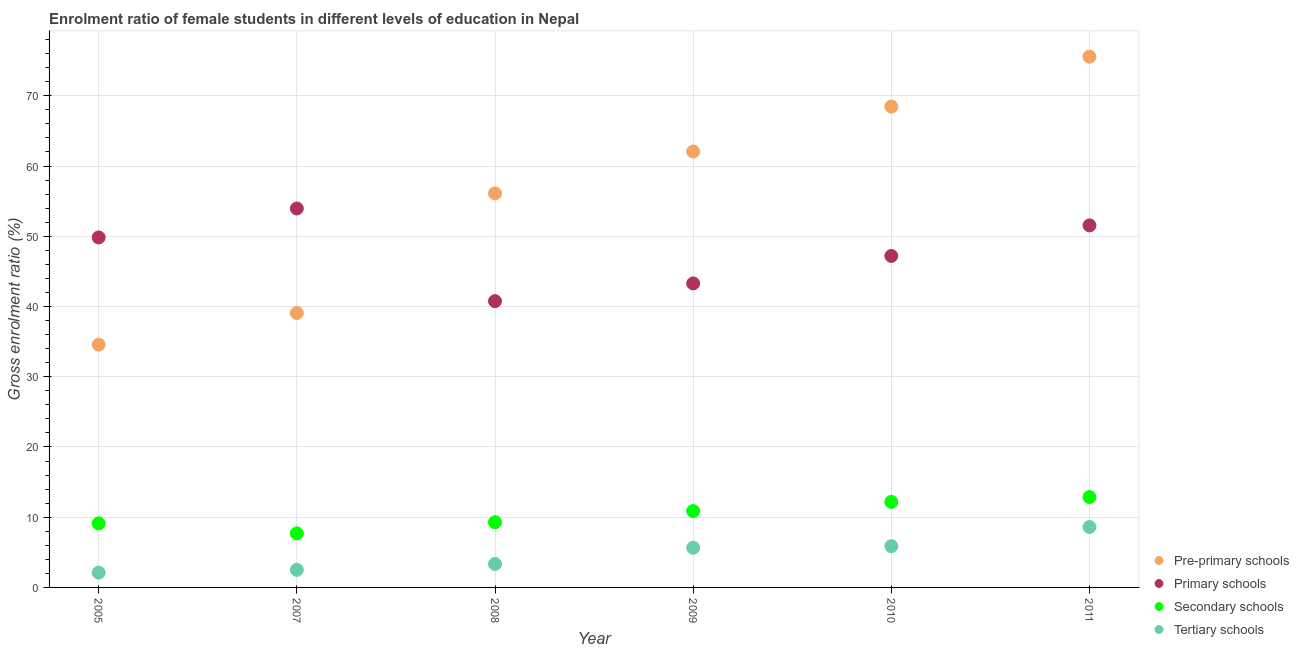How many different coloured dotlines are there?
Provide a short and direct response. 4. Is the number of dotlines equal to the number of legend labels?
Your answer should be compact. Yes. What is the gross enrolment ratio(male) in pre-primary schools in 2009?
Give a very brief answer. 62.07. Across all years, what is the maximum gross enrolment ratio(male) in secondary schools?
Ensure brevity in your answer.  12.86. Across all years, what is the minimum gross enrolment ratio(male) in pre-primary schools?
Offer a very short reply. 34.57. In which year was the gross enrolment ratio(male) in tertiary schools maximum?
Your response must be concise. 2011. What is the total gross enrolment ratio(male) in secondary schools in the graph?
Offer a very short reply. 62. What is the difference between the gross enrolment ratio(male) in pre-primary schools in 2007 and that in 2008?
Ensure brevity in your answer.  -17.03. What is the difference between the gross enrolment ratio(male) in secondary schools in 2010 and the gross enrolment ratio(male) in tertiary schools in 2009?
Provide a succinct answer. 6.53. What is the average gross enrolment ratio(male) in secondary schools per year?
Provide a succinct answer. 10.33. In the year 2011, what is the difference between the gross enrolment ratio(male) in secondary schools and gross enrolment ratio(male) in pre-primary schools?
Offer a very short reply. -62.71. In how many years, is the gross enrolment ratio(male) in tertiary schools greater than 16 %?
Your response must be concise. 0. What is the ratio of the gross enrolment ratio(male) in primary schools in 2007 to that in 2009?
Provide a succinct answer. 1.25. Is the difference between the gross enrolment ratio(male) in tertiary schools in 2005 and 2011 greater than the difference between the gross enrolment ratio(male) in secondary schools in 2005 and 2011?
Offer a very short reply. No. What is the difference between the highest and the second highest gross enrolment ratio(male) in tertiary schools?
Ensure brevity in your answer.  2.73. What is the difference between the highest and the lowest gross enrolment ratio(male) in secondary schools?
Provide a short and direct response. 5.17. In how many years, is the gross enrolment ratio(male) in secondary schools greater than the average gross enrolment ratio(male) in secondary schools taken over all years?
Make the answer very short. 3. Is the sum of the gross enrolment ratio(male) in primary schools in 2010 and 2011 greater than the maximum gross enrolment ratio(male) in pre-primary schools across all years?
Offer a very short reply. Yes. Is the gross enrolment ratio(male) in tertiary schools strictly less than the gross enrolment ratio(male) in secondary schools over the years?
Your response must be concise. Yes. How many dotlines are there?
Offer a terse response. 4. How many years are there in the graph?
Offer a terse response. 6. What is the difference between two consecutive major ticks on the Y-axis?
Provide a succinct answer. 10. Are the values on the major ticks of Y-axis written in scientific E-notation?
Make the answer very short. No. Does the graph contain any zero values?
Make the answer very short. No. Where does the legend appear in the graph?
Provide a short and direct response. Bottom right. How are the legend labels stacked?
Offer a very short reply. Vertical. What is the title of the graph?
Ensure brevity in your answer.  Enrolment ratio of female students in different levels of education in Nepal. Does "Energy" appear as one of the legend labels in the graph?
Your answer should be very brief. No. What is the label or title of the X-axis?
Offer a terse response. Year. What is the label or title of the Y-axis?
Offer a very short reply. Gross enrolment ratio (%). What is the Gross enrolment ratio (%) in Pre-primary schools in 2005?
Make the answer very short. 34.57. What is the Gross enrolment ratio (%) of Primary schools in 2005?
Provide a succinct answer. 49.83. What is the Gross enrolment ratio (%) in Secondary schools in 2005?
Offer a terse response. 9.12. What is the Gross enrolment ratio (%) in Tertiary schools in 2005?
Your answer should be very brief. 2.1. What is the Gross enrolment ratio (%) in Pre-primary schools in 2007?
Make the answer very short. 39.07. What is the Gross enrolment ratio (%) of Primary schools in 2007?
Provide a succinct answer. 53.95. What is the Gross enrolment ratio (%) in Secondary schools in 2007?
Offer a very short reply. 7.69. What is the Gross enrolment ratio (%) in Tertiary schools in 2007?
Your answer should be compact. 2.5. What is the Gross enrolment ratio (%) in Pre-primary schools in 2008?
Your response must be concise. 56.1. What is the Gross enrolment ratio (%) of Primary schools in 2008?
Provide a short and direct response. 40.76. What is the Gross enrolment ratio (%) in Secondary schools in 2008?
Offer a terse response. 9.28. What is the Gross enrolment ratio (%) of Tertiary schools in 2008?
Provide a short and direct response. 3.34. What is the Gross enrolment ratio (%) of Pre-primary schools in 2009?
Your response must be concise. 62.07. What is the Gross enrolment ratio (%) of Primary schools in 2009?
Make the answer very short. 43.28. What is the Gross enrolment ratio (%) of Secondary schools in 2009?
Provide a succinct answer. 10.87. What is the Gross enrolment ratio (%) of Tertiary schools in 2009?
Provide a short and direct response. 5.65. What is the Gross enrolment ratio (%) of Pre-primary schools in 2010?
Provide a short and direct response. 68.46. What is the Gross enrolment ratio (%) of Primary schools in 2010?
Provide a short and direct response. 47.2. What is the Gross enrolment ratio (%) in Secondary schools in 2010?
Your response must be concise. 12.18. What is the Gross enrolment ratio (%) of Tertiary schools in 2010?
Provide a short and direct response. 5.88. What is the Gross enrolment ratio (%) of Pre-primary schools in 2011?
Keep it short and to the point. 75.58. What is the Gross enrolment ratio (%) of Primary schools in 2011?
Make the answer very short. 51.54. What is the Gross enrolment ratio (%) in Secondary schools in 2011?
Ensure brevity in your answer.  12.86. What is the Gross enrolment ratio (%) in Tertiary schools in 2011?
Give a very brief answer. 8.6. Across all years, what is the maximum Gross enrolment ratio (%) in Pre-primary schools?
Offer a terse response. 75.58. Across all years, what is the maximum Gross enrolment ratio (%) in Primary schools?
Provide a short and direct response. 53.95. Across all years, what is the maximum Gross enrolment ratio (%) in Secondary schools?
Your answer should be very brief. 12.86. Across all years, what is the maximum Gross enrolment ratio (%) in Tertiary schools?
Keep it short and to the point. 8.6. Across all years, what is the minimum Gross enrolment ratio (%) in Pre-primary schools?
Make the answer very short. 34.57. Across all years, what is the minimum Gross enrolment ratio (%) of Primary schools?
Provide a succinct answer. 40.76. Across all years, what is the minimum Gross enrolment ratio (%) of Secondary schools?
Ensure brevity in your answer.  7.69. Across all years, what is the minimum Gross enrolment ratio (%) of Tertiary schools?
Your answer should be very brief. 2.1. What is the total Gross enrolment ratio (%) of Pre-primary schools in the graph?
Keep it short and to the point. 335.84. What is the total Gross enrolment ratio (%) in Primary schools in the graph?
Offer a very short reply. 286.57. What is the total Gross enrolment ratio (%) in Secondary schools in the graph?
Offer a very short reply. 62. What is the total Gross enrolment ratio (%) in Tertiary schools in the graph?
Make the answer very short. 28.08. What is the difference between the Gross enrolment ratio (%) of Pre-primary schools in 2005 and that in 2007?
Provide a succinct answer. -4.5. What is the difference between the Gross enrolment ratio (%) in Primary schools in 2005 and that in 2007?
Your answer should be very brief. -4.12. What is the difference between the Gross enrolment ratio (%) of Secondary schools in 2005 and that in 2007?
Offer a terse response. 1.42. What is the difference between the Gross enrolment ratio (%) in Tertiary schools in 2005 and that in 2007?
Keep it short and to the point. -0.39. What is the difference between the Gross enrolment ratio (%) of Pre-primary schools in 2005 and that in 2008?
Provide a succinct answer. -21.53. What is the difference between the Gross enrolment ratio (%) in Primary schools in 2005 and that in 2008?
Keep it short and to the point. 9.07. What is the difference between the Gross enrolment ratio (%) of Secondary schools in 2005 and that in 2008?
Provide a succinct answer. -0.16. What is the difference between the Gross enrolment ratio (%) in Tertiary schools in 2005 and that in 2008?
Ensure brevity in your answer.  -1.24. What is the difference between the Gross enrolment ratio (%) of Pre-primary schools in 2005 and that in 2009?
Provide a short and direct response. -27.5. What is the difference between the Gross enrolment ratio (%) in Primary schools in 2005 and that in 2009?
Offer a terse response. 6.55. What is the difference between the Gross enrolment ratio (%) of Secondary schools in 2005 and that in 2009?
Your answer should be compact. -1.75. What is the difference between the Gross enrolment ratio (%) in Tertiary schools in 2005 and that in 2009?
Keep it short and to the point. -3.55. What is the difference between the Gross enrolment ratio (%) in Pre-primary schools in 2005 and that in 2010?
Your response must be concise. -33.89. What is the difference between the Gross enrolment ratio (%) of Primary schools in 2005 and that in 2010?
Give a very brief answer. 2.63. What is the difference between the Gross enrolment ratio (%) in Secondary schools in 2005 and that in 2010?
Your answer should be very brief. -3.07. What is the difference between the Gross enrolment ratio (%) of Tertiary schools in 2005 and that in 2010?
Your response must be concise. -3.77. What is the difference between the Gross enrolment ratio (%) in Pre-primary schools in 2005 and that in 2011?
Give a very brief answer. -41.01. What is the difference between the Gross enrolment ratio (%) of Primary schools in 2005 and that in 2011?
Your answer should be very brief. -1.71. What is the difference between the Gross enrolment ratio (%) of Secondary schools in 2005 and that in 2011?
Keep it short and to the point. -3.75. What is the difference between the Gross enrolment ratio (%) of Tertiary schools in 2005 and that in 2011?
Your answer should be very brief. -6.5. What is the difference between the Gross enrolment ratio (%) in Pre-primary schools in 2007 and that in 2008?
Your answer should be very brief. -17.03. What is the difference between the Gross enrolment ratio (%) in Primary schools in 2007 and that in 2008?
Offer a terse response. 13.19. What is the difference between the Gross enrolment ratio (%) of Secondary schools in 2007 and that in 2008?
Give a very brief answer. -1.59. What is the difference between the Gross enrolment ratio (%) in Tertiary schools in 2007 and that in 2008?
Ensure brevity in your answer.  -0.85. What is the difference between the Gross enrolment ratio (%) of Pre-primary schools in 2007 and that in 2009?
Keep it short and to the point. -23. What is the difference between the Gross enrolment ratio (%) in Primary schools in 2007 and that in 2009?
Keep it short and to the point. 10.67. What is the difference between the Gross enrolment ratio (%) of Secondary schools in 2007 and that in 2009?
Your answer should be compact. -3.17. What is the difference between the Gross enrolment ratio (%) in Tertiary schools in 2007 and that in 2009?
Provide a short and direct response. -3.16. What is the difference between the Gross enrolment ratio (%) of Pre-primary schools in 2007 and that in 2010?
Provide a succinct answer. -29.39. What is the difference between the Gross enrolment ratio (%) in Primary schools in 2007 and that in 2010?
Provide a succinct answer. 6.76. What is the difference between the Gross enrolment ratio (%) of Secondary schools in 2007 and that in 2010?
Give a very brief answer. -4.49. What is the difference between the Gross enrolment ratio (%) in Tertiary schools in 2007 and that in 2010?
Your answer should be very brief. -3.38. What is the difference between the Gross enrolment ratio (%) of Pre-primary schools in 2007 and that in 2011?
Offer a very short reply. -36.51. What is the difference between the Gross enrolment ratio (%) in Primary schools in 2007 and that in 2011?
Your answer should be very brief. 2.41. What is the difference between the Gross enrolment ratio (%) of Secondary schools in 2007 and that in 2011?
Make the answer very short. -5.17. What is the difference between the Gross enrolment ratio (%) of Tertiary schools in 2007 and that in 2011?
Offer a terse response. -6.11. What is the difference between the Gross enrolment ratio (%) of Pre-primary schools in 2008 and that in 2009?
Your response must be concise. -5.97. What is the difference between the Gross enrolment ratio (%) of Primary schools in 2008 and that in 2009?
Your response must be concise. -2.52. What is the difference between the Gross enrolment ratio (%) in Secondary schools in 2008 and that in 2009?
Provide a succinct answer. -1.59. What is the difference between the Gross enrolment ratio (%) in Tertiary schools in 2008 and that in 2009?
Keep it short and to the point. -2.31. What is the difference between the Gross enrolment ratio (%) in Pre-primary schools in 2008 and that in 2010?
Ensure brevity in your answer.  -12.36. What is the difference between the Gross enrolment ratio (%) of Primary schools in 2008 and that in 2010?
Your response must be concise. -6.44. What is the difference between the Gross enrolment ratio (%) of Secondary schools in 2008 and that in 2010?
Give a very brief answer. -2.9. What is the difference between the Gross enrolment ratio (%) of Tertiary schools in 2008 and that in 2010?
Keep it short and to the point. -2.53. What is the difference between the Gross enrolment ratio (%) in Pre-primary schools in 2008 and that in 2011?
Your answer should be very brief. -19.48. What is the difference between the Gross enrolment ratio (%) of Primary schools in 2008 and that in 2011?
Give a very brief answer. -10.79. What is the difference between the Gross enrolment ratio (%) of Secondary schools in 2008 and that in 2011?
Make the answer very short. -3.58. What is the difference between the Gross enrolment ratio (%) in Tertiary schools in 2008 and that in 2011?
Your answer should be very brief. -5.26. What is the difference between the Gross enrolment ratio (%) of Pre-primary schools in 2009 and that in 2010?
Your response must be concise. -6.39. What is the difference between the Gross enrolment ratio (%) in Primary schools in 2009 and that in 2010?
Ensure brevity in your answer.  -3.91. What is the difference between the Gross enrolment ratio (%) in Secondary schools in 2009 and that in 2010?
Provide a succinct answer. -1.32. What is the difference between the Gross enrolment ratio (%) in Tertiary schools in 2009 and that in 2010?
Offer a very short reply. -0.22. What is the difference between the Gross enrolment ratio (%) in Pre-primary schools in 2009 and that in 2011?
Your answer should be very brief. -13.51. What is the difference between the Gross enrolment ratio (%) of Primary schools in 2009 and that in 2011?
Give a very brief answer. -8.26. What is the difference between the Gross enrolment ratio (%) in Secondary schools in 2009 and that in 2011?
Your response must be concise. -2. What is the difference between the Gross enrolment ratio (%) in Tertiary schools in 2009 and that in 2011?
Offer a terse response. -2.95. What is the difference between the Gross enrolment ratio (%) in Pre-primary schools in 2010 and that in 2011?
Offer a very short reply. -7.12. What is the difference between the Gross enrolment ratio (%) of Primary schools in 2010 and that in 2011?
Keep it short and to the point. -4.35. What is the difference between the Gross enrolment ratio (%) of Secondary schools in 2010 and that in 2011?
Your answer should be very brief. -0.68. What is the difference between the Gross enrolment ratio (%) in Tertiary schools in 2010 and that in 2011?
Your answer should be very brief. -2.73. What is the difference between the Gross enrolment ratio (%) of Pre-primary schools in 2005 and the Gross enrolment ratio (%) of Primary schools in 2007?
Your answer should be compact. -19.39. What is the difference between the Gross enrolment ratio (%) of Pre-primary schools in 2005 and the Gross enrolment ratio (%) of Secondary schools in 2007?
Offer a very short reply. 26.88. What is the difference between the Gross enrolment ratio (%) in Pre-primary schools in 2005 and the Gross enrolment ratio (%) in Tertiary schools in 2007?
Your answer should be compact. 32.07. What is the difference between the Gross enrolment ratio (%) in Primary schools in 2005 and the Gross enrolment ratio (%) in Secondary schools in 2007?
Your response must be concise. 42.14. What is the difference between the Gross enrolment ratio (%) of Primary schools in 2005 and the Gross enrolment ratio (%) of Tertiary schools in 2007?
Offer a very short reply. 47.33. What is the difference between the Gross enrolment ratio (%) of Secondary schools in 2005 and the Gross enrolment ratio (%) of Tertiary schools in 2007?
Make the answer very short. 6.62. What is the difference between the Gross enrolment ratio (%) in Pre-primary schools in 2005 and the Gross enrolment ratio (%) in Primary schools in 2008?
Keep it short and to the point. -6.19. What is the difference between the Gross enrolment ratio (%) in Pre-primary schools in 2005 and the Gross enrolment ratio (%) in Secondary schools in 2008?
Your answer should be compact. 25.29. What is the difference between the Gross enrolment ratio (%) in Pre-primary schools in 2005 and the Gross enrolment ratio (%) in Tertiary schools in 2008?
Offer a terse response. 31.22. What is the difference between the Gross enrolment ratio (%) of Primary schools in 2005 and the Gross enrolment ratio (%) of Secondary schools in 2008?
Provide a short and direct response. 40.55. What is the difference between the Gross enrolment ratio (%) in Primary schools in 2005 and the Gross enrolment ratio (%) in Tertiary schools in 2008?
Offer a very short reply. 46.49. What is the difference between the Gross enrolment ratio (%) in Secondary schools in 2005 and the Gross enrolment ratio (%) in Tertiary schools in 2008?
Offer a terse response. 5.77. What is the difference between the Gross enrolment ratio (%) in Pre-primary schools in 2005 and the Gross enrolment ratio (%) in Primary schools in 2009?
Offer a terse response. -8.72. What is the difference between the Gross enrolment ratio (%) of Pre-primary schools in 2005 and the Gross enrolment ratio (%) of Secondary schools in 2009?
Offer a very short reply. 23.7. What is the difference between the Gross enrolment ratio (%) of Pre-primary schools in 2005 and the Gross enrolment ratio (%) of Tertiary schools in 2009?
Make the answer very short. 28.91. What is the difference between the Gross enrolment ratio (%) in Primary schools in 2005 and the Gross enrolment ratio (%) in Secondary schools in 2009?
Offer a terse response. 38.96. What is the difference between the Gross enrolment ratio (%) of Primary schools in 2005 and the Gross enrolment ratio (%) of Tertiary schools in 2009?
Offer a terse response. 44.18. What is the difference between the Gross enrolment ratio (%) of Secondary schools in 2005 and the Gross enrolment ratio (%) of Tertiary schools in 2009?
Provide a short and direct response. 3.46. What is the difference between the Gross enrolment ratio (%) in Pre-primary schools in 2005 and the Gross enrolment ratio (%) in Primary schools in 2010?
Your answer should be compact. -12.63. What is the difference between the Gross enrolment ratio (%) of Pre-primary schools in 2005 and the Gross enrolment ratio (%) of Secondary schools in 2010?
Your answer should be very brief. 22.39. What is the difference between the Gross enrolment ratio (%) of Pre-primary schools in 2005 and the Gross enrolment ratio (%) of Tertiary schools in 2010?
Your response must be concise. 28.69. What is the difference between the Gross enrolment ratio (%) of Primary schools in 2005 and the Gross enrolment ratio (%) of Secondary schools in 2010?
Your response must be concise. 37.65. What is the difference between the Gross enrolment ratio (%) in Primary schools in 2005 and the Gross enrolment ratio (%) in Tertiary schools in 2010?
Make the answer very short. 43.95. What is the difference between the Gross enrolment ratio (%) of Secondary schools in 2005 and the Gross enrolment ratio (%) of Tertiary schools in 2010?
Provide a short and direct response. 3.24. What is the difference between the Gross enrolment ratio (%) of Pre-primary schools in 2005 and the Gross enrolment ratio (%) of Primary schools in 2011?
Make the answer very short. -16.98. What is the difference between the Gross enrolment ratio (%) in Pre-primary schools in 2005 and the Gross enrolment ratio (%) in Secondary schools in 2011?
Your answer should be very brief. 21.7. What is the difference between the Gross enrolment ratio (%) in Pre-primary schools in 2005 and the Gross enrolment ratio (%) in Tertiary schools in 2011?
Provide a short and direct response. 25.96. What is the difference between the Gross enrolment ratio (%) of Primary schools in 2005 and the Gross enrolment ratio (%) of Secondary schools in 2011?
Provide a succinct answer. 36.97. What is the difference between the Gross enrolment ratio (%) of Primary schools in 2005 and the Gross enrolment ratio (%) of Tertiary schools in 2011?
Your response must be concise. 41.23. What is the difference between the Gross enrolment ratio (%) in Secondary schools in 2005 and the Gross enrolment ratio (%) in Tertiary schools in 2011?
Your answer should be very brief. 0.51. What is the difference between the Gross enrolment ratio (%) in Pre-primary schools in 2007 and the Gross enrolment ratio (%) in Primary schools in 2008?
Offer a very short reply. -1.69. What is the difference between the Gross enrolment ratio (%) in Pre-primary schools in 2007 and the Gross enrolment ratio (%) in Secondary schools in 2008?
Make the answer very short. 29.79. What is the difference between the Gross enrolment ratio (%) of Pre-primary schools in 2007 and the Gross enrolment ratio (%) of Tertiary schools in 2008?
Keep it short and to the point. 35.73. What is the difference between the Gross enrolment ratio (%) in Primary schools in 2007 and the Gross enrolment ratio (%) in Secondary schools in 2008?
Your response must be concise. 44.67. What is the difference between the Gross enrolment ratio (%) of Primary schools in 2007 and the Gross enrolment ratio (%) of Tertiary schools in 2008?
Your response must be concise. 50.61. What is the difference between the Gross enrolment ratio (%) in Secondary schools in 2007 and the Gross enrolment ratio (%) in Tertiary schools in 2008?
Make the answer very short. 4.35. What is the difference between the Gross enrolment ratio (%) in Pre-primary schools in 2007 and the Gross enrolment ratio (%) in Primary schools in 2009?
Provide a succinct answer. -4.21. What is the difference between the Gross enrolment ratio (%) of Pre-primary schools in 2007 and the Gross enrolment ratio (%) of Secondary schools in 2009?
Provide a succinct answer. 28.2. What is the difference between the Gross enrolment ratio (%) of Pre-primary schools in 2007 and the Gross enrolment ratio (%) of Tertiary schools in 2009?
Your answer should be compact. 33.42. What is the difference between the Gross enrolment ratio (%) of Primary schools in 2007 and the Gross enrolment ratio (%) of Secondary schools in 2009?
Keep it short and to the point. 43.09. What is the difference between the Gross enrolment ratio (%) of Primary schools in 2007 and the Gross enrolment ratio (%) of Tertiary schools in 2009?
Keep it short and to the point. 48.3. What is the difference between the Gross enrolment ratio (%) in Secondary schools in 2007 and the Gross enrolment ratio (%) in Tertiary schools in 2009?
Your answer should be compact. 2.04. What is the difference between the Gross enrolment ratio (%) in Pre-primary schools in 2007 and the Gross enrolment ratio (%) in Primary schools in 2010?
Offer a very short reply. -8.13. What is the difference between the Gross enrolment ratio (%) in Pre-primary schools in 2007 and the Gross enrolment ratio (%) in Secondary schools in 2010?
Your answer should be compact. 26.89. What is the difference between the Gross enrolment ratio (%) in Pre-primary schools in 2007 and the Gross enrolment ratio (%) in Tertiary schools in 2010?
Your answer should be very brief. 33.19. What is the difference between the Gross enrolment ratio (%) of Primary schools in 2007 and the Gross enrolment ratio (%) of Secondary schools in 2010?
Offer a very short reply. 41.77. What is the difference between the Gross enrolment ratio (%) of Primary schools in 2007 and the Gross enrolment ratio (%) of Tertiary schools in 2010?
Keep it short and to the point. 48.08. What is the difference between the Gross enrolment ratio (%) of Secondary schools in 2007 and the Gross enrolment ratio (%) of Tertiary schools in 2010?
Give a very brief answer. 1.82. What is the difference between the Gross enrolment ratio (%) in Pre-primary schools in 2007 and the Gross enrolment ratio (%) in Primary schools in 2011?
Your answer should be very brief. -12.47. What is the difference between the Gross enrolment ratio (%) of Pre-primary schools in 2007 and the Gross enrolment ratio (%) of Secondary schools in 2011?
Give a very brief answer. 26.21. What is the difference between the Gross enrolment ratio (%) in Pre-primary schools in 2007 and the Gross enrolment ratio (%) in Tertiary schools in 2011?
Give a very brief answer. 30.47. What is the difference between the Gross enrolment ratio (%) of Primary schools in 2007 and the Gross enrolment ratio (%) of Secondary schools in 2011?
Provide a short and direct response. 41.09. What is the difference between the Gross enrolment ratio (%) in Primary schools in 2007 and the Gross enrolment ratio (%) in Tertiary schools in 2011?
Your response must be concise. 45.35. What is the difference between the Gross enrolment ratio (%) in Secondary schools in 2007 and the Gross enrolment ratio (%) in Tertiary schools in 2011?
Provide a succinct answer. -0.91. What is the difference between the Gross enrolment ratio (%) in Pre-primary schools in 2008 and the Gross enrolment ratio (%) in Primary schools in 2009?
Keep it short and to the point. 12.82. What is the difference between the Gross enrolment ratio (%) of Pre-primary schools in 2008 and the Gross enrolment ratio (%) of Secondary schools in 2009?
Make the answer very short. 45.23. What is the difference between the Gross enrolment ratio (%) of Pre-primary schools in 2008 and the Gross enrolment ratio (%) of Tertiary schools in 2009?
Give a very brief answer. 50.45. What is the difference between the Gross enrolment ratio (%) of Primary schools in 2008 and the Gross enrolment ratio (%) of Secondary schools in 2009?
Your answer should be compact. 29.89. What is the difference between the Gross enrolment ratio (%) in Primary schools in 2008 and the Gross enrolment ratio (%) in Tertiary schools in 2009?
Your response must be concise. 35.11. What is the difference between the Gross enrolment ratio (%) in Secondary schools in 2008 and the Gross enrolment ratio (%) in Tertiary schools in 2009?
Offer a very short reply. 3.63. What is the difference between the Gross enrolment ratio (%) of Pre-primary schools in 2008 and the Gross enrolment ratio (%) of Primary schools in 2010?
Offer a terse response. 8.9. What is the difference between the Gross enrolment ratio (%) of Pre-primary schools in 2008 and the Gross enrolment ratio (%) of Secondary schools in 2010?
Keep it short and to the point. 43.92. What is the difference between the Gross enrolment ratio (%) of Pre-primary schools in 2008 and the Gross enrolment ratio (%) of Tertiary schools in 2010?
Make the answer very short. 50.22. What is the difference between the Gross enrolment ratio (%) in Primary schools in 2008 and the Gross enrolment ratio (%) in Secondary schools in 2010?
Keep it short and to the point. 28.58. What is the difference between the Gross enrolment ratio (%) in Primary schools in 2008 and the Gross enrolment ratio (%) in Tertiary schools in 2010?
Give a very brief answer. 34.88. What is the difference between the Gross enrolment ratio (%) in Secondary schools in 2008 and the Gross enrolment ratio (%) in Tertiary schools in 2010?
Your answer should be very brief. 3.4. What is the difference between the Gross enrolment ratio (%) in Pre-primary schools in 2008 and the Gross enrolment ratio (%) in Primary schools in 2011?
Make the answer very short. 4.55. What is the difference between the Gross enrolment ratio (%) in Pre-primary schools in 2008 and the Gross enrolment ratio (%) in Secondary schools in 2011?
Offer a very short reply. 43.23. What is the difference between the Gross enrolment ratio (%) of Pre-primary schools in 2008 and the Gross enrolment ratio (%) of Tertiary schools in 2011?
Your response must be concise. 47.49. What is the difference between the Gross enrolment ratio (%) of Primary schools in 2008 and the Gross enrolment ratio (%) of Secondary schools in 2011?
Keep it short and to the point. 27.89. What is the difference between the Gross enrolment ratio (%) in Primary schools in 2008 and the Gross enrolment ratio (%) in Tertiary schools in 2011?
Make the answer very short. 32.15. What is the difference between the Gross enrolment ratio (%) in Secondary schools in 2008 and the Gross enrolment ratio (%) in Tertiary schools in 2011?
Provide a succinct answer. 0.68. What is the difference between the Gross enrolment ratio (%) in Pre-primary schools in 2009 and the Gross enrolment ratio (%) in Primary schools in 2010?
Keep it short and to the point. 14.87. What is the difference between the Gross enrolment ratio (%) in Pre-primary schools in 2009 and the Gross enrolment ratio (%) in Secondary schools in 2010?
Offer a terse response. 49.89. What is the difference between the Gross enrolment ratio (%) in Pre-primary schools in 2009 and the Gross enrolment ratio (%) in Tertiary schools in 2010?
Offer a terse response. 56.19. What is the difference between the Gross enrolment ratio (%) in Primary schools in 2009 and the Gross enrolment ratio (%) in Secondary schools in 2010?
Ensure brevity in your answer.  31.1. What is the difference between the Gross enrolment ratio (%) of Primary schools in 2009 and the Gross enrolment ratio (%) of Tertiary schools in 2010?
Offer a terse response. 37.41. What is the difference between the Gross enrolment ratio (%) of Secondary schools in 2009 and the Gross enrolment ratio (%) of Tertiary schools in 2010?
Ensure brevity in your answer.  4.99. What is the difference between the Gross enrolment ratio (%) in Pre-primary schools in 2009 and the Gross enrolment ratio (%) in Primary schools in 2011?
Your response must be concise. 10.52. What is the difference between the Gross enrolment ratio (%) in Pre-primary schools in 2009 and the Gross enrolment ratio (%) in Secondary schools in 2011?
Provide a succinct answer. 49.2. What is the difference between the Gross enrolment ratio (%) of Pre-primary schools in 2009 and the Gross enrolment ratio (%) of Tertiary schools in 2011?
Give a very brief answer. 53.46. What is the difference between the Gross enrolment ratio (%) in Primary schools in 2009 and the Gross enrolment ratio (%) in Secondary schools in 2011?
Keep it short and to the point. 30.42. What is the difference between the Gross enrolment ratio (%) in Primary schools in 2009 and the Gross enrolment ratio (%) in Tertiary schools in 2011?
Offer a terse response. 34.68. What is the difference between the Gross enrolment ratio (%) in Secondary schools in 2009 and the Gross enrolment ratio (%) in Tertiary schools in 2011?
Make the answer very short. 2.26. What is the difference between the Gross enrolment ratio (%) in Pre-primary schools in 2010 and the Gross enrolment ratio (%) in Primary schools in 2011?
Give a very brief answer. 16.91. What is the difference between the Gross enrolment ratio (%) in Pre-primary schools in 2010 and the Gross enrolment ratio (%) in Secondary schools in 2011?
Your answer should be very brief. 55.59. What is the difference between the Gross enrolment ratio (%) in Pre-primary schools in 2010 and the Gross enrolment ratio (%) in Tertiary schools in 2011?
Provide a short and direct response. 59.85. What is the difference between the Gross enrolment ratio (%) in Primary schools in 2010 and the Gross enrolment ratio (%) in Secondary schools in 2011?
Offer a terse response. 34.33. What is the difference between the Gross enrolment ratio (%) in Primary schools in 2010 and the Gross enrolment ratio (%) in Tertiary schools in 2011?
Ensure brevity in your answer.  38.59. What is the difference between the Gross enrolment ratio (%) in Secondary schools in 2010 and the Gross enrolment ratio (%) in Tertiary schools in 2011?
Give a very brief answer. 3.58. What is the average Gross enrolment ratio (%) in Pre-primary schools per year?
Your response must be concise. 55.97. What is the average Gross enrolment ratio (%) in Primary schools per year?
Give a very brief answer. 47.76. What is the average Gross enrolment ratio (%) in Secondary schools per year?
Your answer should be compact. 10.33. What is the average Gross enrolment ratio (%) in Tertiary schools per year?
Ensure brevity in your answer.  4.68. In the year 2005, what is the difference between the Gross enrolment ratio (%) in Pre-primary schools and Gross enrolment ratio (%) in Primary schools?
Offer a very short reply. -15.26. In the year 2005, what is the difference between the Gross enrolment ratio (%) in Pre-primary schools and Gross enrolment ratio (%) in Secondary schools?
Keep it short and to the point. 25.45. In the year 2005, what is the difference between the Gross enrolment ratio (%) of Pre-primary schools and Gross enrolment ratio (%) of Tertiary schools?
Your answer should be compact. 32.46. In the year 2005, what is the difference between the Gross enrolment ratio (%) of Primary schools and Gross enrolment ratio (%) of Secondary schools?
Give a very brief answer. 40.71. In the year 2005, what is the difference between the Gross enrolment ratio (%) in Primary schools and Gross enrolment ratio (%) in Tertiary schools?
Make the answer very short. 47.73. In the year 2005, what is the difference between the Gross enrolment ratio (%) in Secondary schools and Gross enrolment ratio (%) in Tertiary schools?
Provide a short and direct response. 7.01. In the year 2007, what is the difference between the Gross enrolment ratio (%) in Pre-primary schools and Gross enrolment ratio (%) in Primary schools?
Your response must be concise. -14.88. In the year 2007, what is the difference between the Gross enrolment ratio (%) in Pre-primary schools and Gross enrolment ratio (%) in Secondary schools?
Offer a terse response. 31.38. In the year 2007, what is the difference between the Gross enrolment ratio (%) of Pre-primary schools and Gross enrolment ratio (%) of Tertiary schools?
Provide a short and direct response. 36.57. In the year 2007, what is the difference between the Gross enrolment ratio (%) of Primary schools and Gross enrolment ratio (%) of Secondary schools?
Your answer should be very brief. 46.26. In the year 2007, what is the difference between the Gross enrolment ratio (%) of Primary schools and Gross enrolment ratio (%) of Tertiary schools?
Offer a very short reply. 51.46. In the year 2007, what is the difference between the Gross enrolment ratio (%) of Secondary schools and Gross enrolment ratio (%) of Tertiary schools?
Make the answer very short. 5.19. In the year 2008, what is the difference between the Gross enrolment ratio (%) in Pre-primary schools and Gross enrolment ratio (%) in Primary schools?
Provide a succinct answer. 15.34. In the year 2008, what is the difference between the Gross enrolment ratio (%) in Pre-primary schools and Gross enrolment ratio (%) in Secondary schools?
Your answer should be very brief. 46.82. In the year 2008, what is the difference between the Gross enrolment ratio (%) of Pre-primary schools and Gross enrolment ratio (%) of Tertiary schools?
Give a very brief answer. 52.75. In the year 2008, what is the difference between the Gross enrolment ratio (%) of Primary schools and Gross enrolment ratio (%) of Secondary schools?
Keep it short and to the point. 31.48. In the year 2008, what is the difference between the Gross enrolment ratio (%) of Primary schools and Gross enrolment ratio (%) of Tertiary schools?
Offer a terse response. 37.41. In the year 2008, what is the difference between the Gross enrolment ratio (%) in Secondary schools and Gross enrolment ratio (%) in Tertiary schools?
Give a very brief answer. 5.94. In the year 2009, what is the difference between the Gross enrolment ratio (%) in Pre-primary schools and Gross enrolment ratio (%) in Primary schools?
Your answer should be compact. 18.79. In the year 2009, what is the difference between the Gross enrolment ratio (%) of Pre-primary schools and Gross enrolment ratio (%) of Secondary schools?
Give a very brief answer. 51.2. In the year 2009, what is the difference between the Gross enrolment ratio (%) in Pre-primary schools and Gross enrolment ratio (%) in Tertiary schools?
Your answer should be very brief. 56.42. In the year 2009, what is the difference between the Gross enrolment ratio (%) of Primary schools and Gross enrolment ratio (%) of Secondary schools?
Provide a short and direct response. 32.42. In the year 2009, what is the difference between the Gross enrolment ratio (%) of Primary schools and Gross enrolment ratio (%) of Tertiary schools?
Your response must be concise. 37.63. In the year 2009, what is the difference between the Gross enrolment ratio (%) of Secondary schools and Gross enrolment ratio (%) of Tertiary schools?
Provide a short and direct response. 5.21. In the year 2010, what is the difference between the Gross enrolment ratio (%) in Pre-primary schools and Gross enrolment ratio (%) in Primary schools?
Offer a very short reply. 21.26. In the year 2010, what is the difference between the Gross enrolment ratio (%) in Pre-primary schools and Gross enrolment ratio (%) in Secondary schools?
Give a very brief answer. 56.28. In the year 2010, what is the difference between the Gross enrolment ratio (%) in Pre-primary schools and Gross enrolment ratio (%) in Tertiary schools?
Offer a terse response. 62.58. In the year 2010, what is the difference between the Gross enrolment ratio (%) in Primary schools and Gross enrolment ratio (%) in Secondary schools?
Make the answer very short. 35.01. In the year 2010, what is the difference between the Gross enrolment ratio (%) of Primary schools and Gross enrolment ratio (%) of Tertiary schools?
Give a very brief answer. 41.32. In the year 2010, what is the difference between the Gross enrolment ratio (%) in Secondary schools and Gross enrolment ratio (%) in Tertiary schools?
Offer a terse response. 6.31. In the year 2011, what is the difference between the Gross enrolment ratio (%) of Pre-primary schools and Gross enrolment ratio (%) of Primary schools?
Provide a short and direct response. 24.03. In the year 2011, what is the difference between the Gross enrolment ratio (%) of Pre-primary schools and Gross enrolment ratio (%) of Secondary schools?
Your answer should be very brief. 62.71. In the year 2011, what is the difference between the Gross enrolment ratio (%) of Pre-primary schools and Gross enrolment ratio (%) of Tertiary schools?
Your answer should be compact. 66.97. In the year 2011, what is the difference between the Gross enrolment ratio (%) in Primary schools and Gross enrolment ratio (%) in Secondary schools?
Make the answer very short. 38.68. In the year 2011, what is the difference between the Gross enrolment ratio (%) in Primary schools and Gross enrolment ratio (%) in Tertiary schools?
Make the answer very short. 42.94. In the year 2011, what is the difference between the Gross enrolment ratio (%) in Secondary schools and Gross enrolment ratio (%) in Tertiary schools?
Keep it short and to the point. 4.26. What is the ratio of the Gross enrolment ratio (%) of Pre-primary schools in 2005 to that in 2007?
Keep it short and to the point. 0.88. What is the ratio of the Gross enrolment ratio (%) of Primary schools in 2005 to that in 2007?
Give a very brief answer. 0.92. What is the ratio of the Gross enrolment ratio (%) in Secondary schools in 2005 to that in 2007?
Offer a terse response. 1.19. What is the ratio of the Gross enrolment ratio (%) of Tertiary schools in 2005 to that in 2007?
Ensure brevity in your answer.  0.84. What is the ratio of the Gross enrolment ratio (%) in Pre-primary schools in 2005 to that in 2008?
Your answer should be compact. 0.62. What is the ratio of the Gross enrolment ratio (%) of Primary schools in 2005 to that in 2008?
Make the answer very short. 1.22. What is the ratio of the Gross enrolment ratio (%) in Secondary schools in 2005 to that in 2008?
Make the answer very short. 0.98. What is the ratio of the Gross enrolment ratio (%) of Tertiary schools in 2005 to that in 2008?
Offer a very short reply. 0.63. What is the ratio of the Gross enrolment ratio (%) of Pre-primary schools in 2005 to that in 2009?
Your answer should be very brief. 0.56. What is the ratio of the Gross enrolment ratio (%) of Primary schools in 2005 to that in 2009?
Keep it short and to the point. 1.15. What is the ratio of the Gross enrolment ratio (%) of Secondary schools in 2005 to that in 2009?
Give a very brief answer. 0.84. What is the ratio of the Gross enrolment ratio (%) of Tertiary schools in 2005 to that in 2009?
Provide a succinct answer. 0.37. What is the ratio of the Gross enrolment ratio (%) of Pre-primary schools in 2005 to that in 2010?
Offer a terse response. 0.5. What is the ratio of the Gross enrolment ratio (%) in Primary schools in 2005 to that in 2010?
Offer a terse response. 1.06. What is the ratio of the Gross enrolment ratio (%) of Secondary schools in 2005 to that in 2010?
Keep it short and to the point. 0.75. What is the ratio of the Gross enrolment ratio (%) in Tertiary schools in 2005 to that in 2010?
Your response must be concise. 0.36. What is the ratio of the Gross enrolment ratio (%) in Pre-primary schools in 2005 to that in 2011?
Keep it short and to the point. 0.46. What is the ratio of the Gross enrolment ratio (%) of Primary schools in 2005 to that in 2011?
Your response must be concise. 0.97. What is the ratio of the Gross enrolment ratio (%) of Secondary schools in 2005 to that in 2011?
Provide a short and direct response. 0.71. What is the ratio of the Gross enrolment ratio (%) of Tertiary schools in 2005 to that in 2011?
Make the answer very short. 0.24. What is the ratio of the Gross enrolment ratio (%) in Pre-primary schools in 2007 to that in 2008?
Offer a very short reply. 0.7. What is the ratio of the Gross enrolment ratio (%) in Primary schools in 2007 to that in 2008?
Ensure brevity in your answer.  1.32. What is the ratio of the Gross enrolment ratio (%) in Secondary schools in 2007 to that in 2008?
Ensure brevity in your answer.  0.83. What is the ratio of the Gross enrolment ratio (%) in Tertiary schools in 2007 to that in 2008?
Your answer should be very brief. 0.75. What is the ratio of the Gross enrolment ratio (%) in Pre-primary schools in 2007 to that in 2009?
Offer a very short reply. 0.63. What is the ratio of the Gross enrolment ratio (%) of Primary schools in 2007 to that in 2009?
Your answer should be compact. 1.25. What is the ratio of the Gross enrolment ratio (%) of Secondary schools in 2007 to that in 2009?
Provide a short and direct response. 0.71. What is the ratio of the Gross enrolment ratio (%) in Tertiary schools in 2007 to that in 2009?
Ensure brevity in your answer.  0.44. What is the ratio of the Gross enrolment ratio (%) of Pre-primary schools in 2007 to that in 2010?
Ensure brevity in your answer.  0.57. What is the ratio of the Gross enrolment ratio (%) of Primary schools in 2007 to that in 2010?
Provide a short and direct response. 1.14. What is the ratio of the Gross enrolment ratio (%) in Secondary schools in 2007 to that in 2010?
Offer a terse response. 0.63. What is the ratio of the Gross enrolment ratio (%) in Tertiary schools in 2007 to that in 2010?
Your answer should be very brief. 0.43. What is the ratio of the Gross enrolment ratio (%) in Pre-primary schools in 2007 to that in 2011?
Provide a succinct answer. 0.52. What is the ratio of the Gross enrolment ratio (%) of Primary schools in 2007 to that in 2011?
Your response must be concise. 1.05. What is the ratio of the Gross enrolment ratio (%) in Secondary schools in 2007 to that in 2011?
Your response must be concise. 0.6. What is the ratio of the Gross enrolment ratio (%) of Tertiary schools in 2007 to that in 2011?
Give a very brief answer. 0.29. What is the ratio of the Gross enrolment ratio (%) in Pre-primary schools in 2008 to that in 2009?
Your response must be concise. 0.9. What is the ratio of the Gross enrolment ratio (%) of Primary schools in 2008 to that in 2009?
Offer a very short reply. 0.94. What is the ratio of the Gross enrolment ratio (%) of Secondary schools in 2008 to that in 2009?
Make the answer very short. 0.85. What is the ratio of the Gross enrolment ratio (%) in Tertiary schools in 2008 to that in 2009?
Your answer should be very brief. 0.59. What is the ratio of the Gross enrolment ratio (%) of Pre-primary schools in 2008 to that in 2010?
Your response must be concise. 0.82. What is the ratio of the Gross enrolment ratio (%) in Primary schools in 2008 to that in 2010?
Make the answer very short. 0.86. What is the ratio of the Gross enrolment ratio (%) in Secondary schools in 2008 to that in 2010?
Make the answer very short. 0.76. What is the ratio of the Gross enrolment ratio (%) in Tertiary schools in 2008 to that in 2010?
Provide a succinct answer. 0.57. What is the ratio of the Gross enrolment ratio (%) of Pre-primary schools in 2008 to that in 2011?
Provide a short and direct response. 0.74. What is the ratio of the Gross enrolment ratio (%) of Primary schools in 2008 to that in 2011?
Provide a succinct answer. 0.79. What is the ratio of the Gross enrolment ratio (%) of Secondary schools in 2008 to that in 2011?
Make the answer very short. 0.72. What is the ratio of the Gross enrolment ratio (%) in Tertiary schools in 2008 to that in 2011?
Offer a very short reply. 0.39. What is the ratio of the Gross enrolment ratio (%) of Pre-primary schools in 2009 to that in 2010?
Your answer should be compact. 0.91. What is the ratio of the Gross enrolment ratio (%) in Primary schools in 2009 to that in 2010?
Offer a terse response. 0.92. What is the ratio of the Gross enrolment ratio (%) in Secondary schools in 2009 to that in 2010?
Your answer should be compact. 0.89. What is the ratio of the Gross enrolment ratio (%) in Tertiary schools in 2009 to that in 2010?
Provide a short and direct response. 0.96. What is the ratio of the Gross enrolment ratio (%) in Pre-primary schools in 2009 to that in 2011?
Make the answer very short. 0.82. What is the ratio of the Gross enrolment ratio (%) in Primary schools in 2009 to that in 2011?
Your answer should be compact. 0.84. What is the ratio of the Gross enrolment ratio (%) of Secondary schools in 2009 to that in 2011?
Make the answer very short. 0.84. What is the ratio of the Gross enrolment ratio (%) of Tertiary schools in 2009 to that in 2011?
Keep it short and to the point. 0.66. What is the ratio of the Gross enrolment ratio (%) of Pre-primary schools in 2010 to that in 2011?
Your answer should be very brief. 0.91. What is the ratio of the Gross enrolment ratio (%) in Primary schools in 2010 to that in 2011?
Your response must be concise. 0.92. What is the ratio of the Gross enrolment ratio (%) of Secondary schools in 2010 to that in 2011?
Provide a short and direct response. 0.95. What is the ratio of the Gross enrolment ratio (%) of Tertiary schools in 2010 to that in 2011?
Your answer should be compact. 0.68. What is the difference between the highest and the second highest Gross enrolment ratio (%) in Pre-primary schools?
Give a very brief answer. 7.12. What is the difference between the highest and the second highest Gross enrolment ratio (%) of Primary schools?
Your response must be concise. 2.41. What is the difference between the highest and the second highest Gross enrolment ratio (%) in Secondary schools?
Provide a succinct answer. 0.68. What is the difference between the highest and the second highest Gross enrolment ratio (%) in Tertiary schools?
Keep it short and to the point. 2.73. What is the difference between the highest and the lowest Gross enrolment ratio (%) of Pre-primary schools?
Offer a very short reply. 41.01. What is the difference between the highest and the lowest Gross enrolment ratio (%) of Primary schools?
Make the answer very short. 13.19. What is the difference between the highest and the lowest Gross enrolment ratio (%) of Secondary schools?
Your answer should be compact. 5.17. What is the difference between the highest and the lowest Gross enrolment ratio (%) of Tertiary schools?
Your answer should be compact. 6.5. 